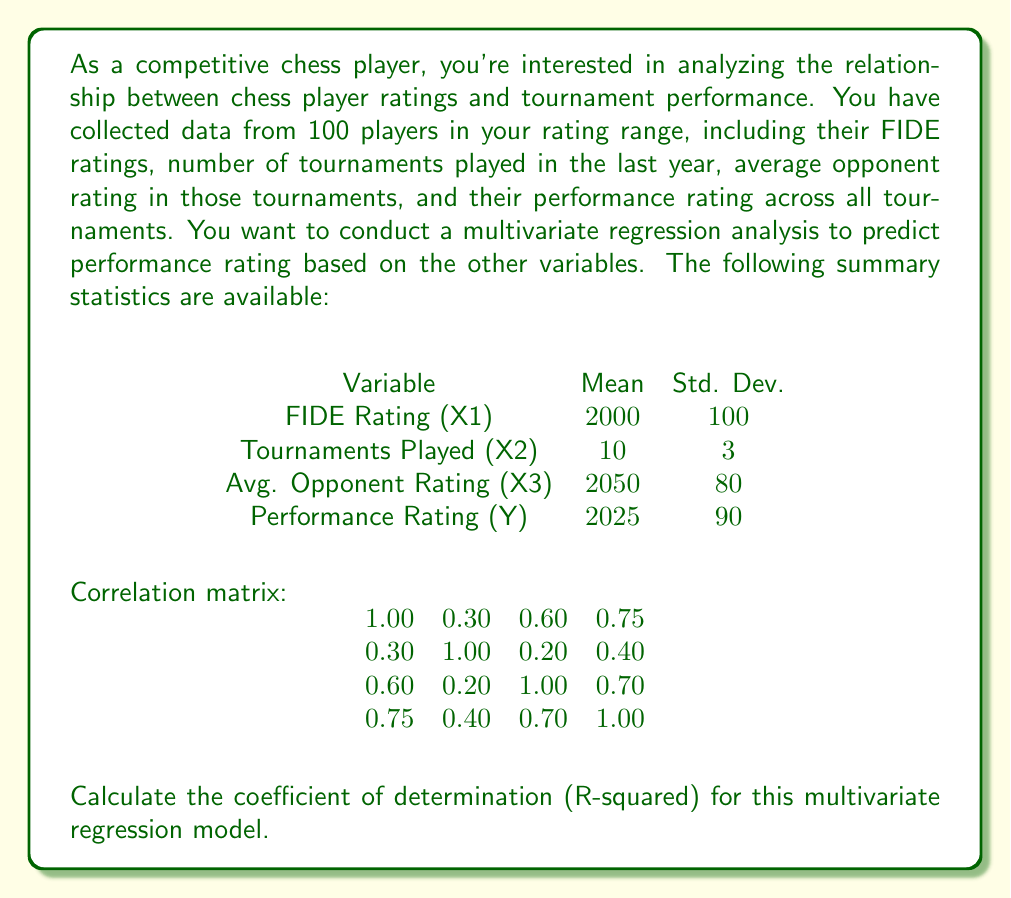Could you help me with this problem? To calculate the coefficient of determination (R-squared) for this multivariate regression model, we'll use the formula:

$$ R^2 = 1 - \frac{SSE}{SST} $$

Where SSE is the sum of squared errors (unexplained variance) and SST is the total sum of squares (total variance).

For multivariate regression, we can calculate R-squared using the correlation matrix. The formula is:

$$ R^2 = \mathbf{r_{Y,X}^T R_{XX}^{-1} r_{Y,X}} $$

Where:
- $\mathbf{r_{Y,X}}$ is the vector of correlations between Y and each X variable
- $\mathbf{R_{XX}}$ is the correlation matrix of the X variables

Step 1: Extract $\mathbf{r_{Y,X}}$ from the correlation matrix:
$$ \mathbf{r_{Y,X}} = \begin{bmatrix} 0.75 \\ 0.40 \\ 0.70 \end{bmatrix} $$

Step 2: Extract $\mathbf{R_{XX}}$ from the correlation matrix:
$$ \mathbf{R_{XX}} = \begin{bmatrix} 
1.00 & 0.30 & 0.60 \\
0.30 & 1.00 & 0.20 \\
0.60 & 0.20 & 1.00
\end{bmatrix} $$

Step 3: Calculate $\mathbf{R_{XX}^{-1}}$ (inverse of $\mathbf{R_{XX}}$):
$$ \mathbf{R_{XX}^{-1}} = \begin{bmatrix} 
1.6129 & -0.2581 & -0.9677 \\
-0.2581 & 1.0968 & -0.0645 \\
-0.9677 & -0.0645 & 1.6129
\end{bmatrix} $$

Step 4: Calculate $R^2$ using the formula:
$$ R^2 = \begin{bmatrix} 0.75 & 0.40 & 0.70 \end{bmatrix} 
\begin{bmatrix} 
1.6129 & -0.2581 & -0.9677 \\
-0.2581 & 1.0968 & -0.0645 \\
-0.9677 & -0.0645 & 1.6129
\end{bmatrix}
\begin{bmatrix} 0.75 \\ 0.40 \\ 0.70 \end{bmatrix} $$

$$ R^2 = \begin{bmatrix} 0.75 & 0.40 & 0.70 \end{bmatrix}
\begin{bmatrix} 0.6452 \\ 0.3226 \\ 0.5161 \end{bmatrix} $$

$$ R^2 = 0.6452 * 0.75 + 0.3226 * 0.40 + 0.5161 * 0.70 $$

$$ R^2 = 0.4839 + 0.1290 + 0.3613 = 0.9742 $$
Answer: The coefficient of determination (R-squared) for this multivariate regression model is approximately 0.9742 or 97.42%. 